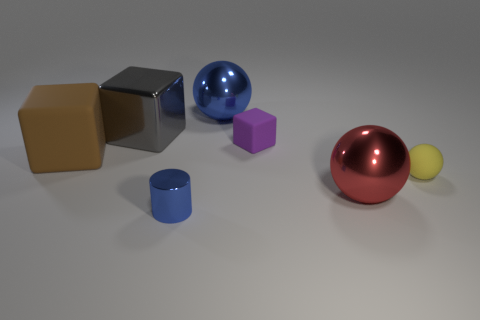Subtract all red metal balls. How many balls are left? 2 Add 1 small purple rubber objects. How many objects exist? 8 Subtract all red balls. How many balls are left? 2 Subtract all cylinders. How many objects are left? 6 Subtract all yellow rubber objects. Subtract all blue metal balls. How many objects are left? 5 Add 3 blue shiny cylinders. How many blue shiny cylinders are left? 4 Add 6 brown matte cubes. How many brown matte cubes exist? 7 Subtract 0 cyan balls. How many objects are left? 7 Subtract 1 balls. How many balls are left? 2 Subtract all blue spheres. Subtract all purple cubes. How many spheres are left? 2 